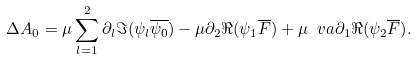<formula> <loc_0><loc_0><loc_500><loc_500>\Delta A _ { 0 } = \mu \sum _ { l = 1 } ^ { 2 } \partial _ { l } \Im ( \psi _ { l } \overline { \psi _ { 0 } } ) - \mu \partial _ { 2 } \Re { ( \psi _ { 1 } \overline { F } ) } + \mu \ v a \partial _ { 1 } \Re { ( \psi _ { 2 } \overline { F } ) } .</formula> 